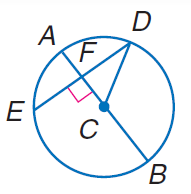Answer the mathemtical geometry problem and directly provide the correct option letter.
Question: If A B = 60 and D E = 48, find C F.
Choices: A: 12 B: 18 C: 24 D: 30 B 